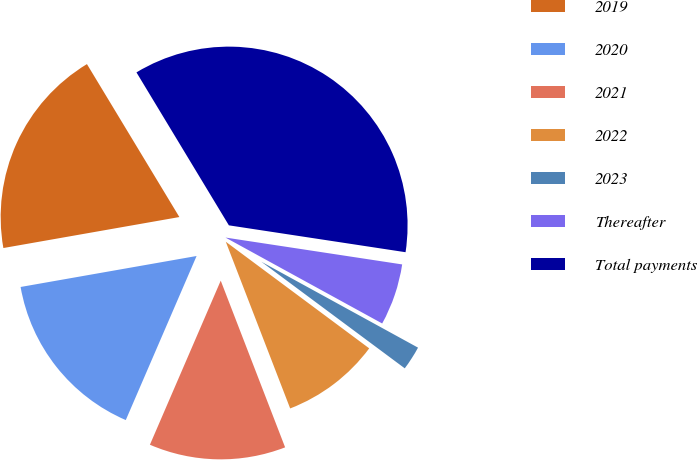Convert chart to OTSL. <chart><loc_0><loc_0><loc_500><loc_500><pie_chart><fcel>2019<fcel>2020<fcel>2021<fcel>2022<fcel>2023<fcel>Thereafter<fcel>Total payments<nl><fcel>19.12%<fcel>15.74%<fcel>12.35%<fcel>8.96%<fcel>2.19%<fcel>5.58%<fcel>36.05%<nl></chart> 